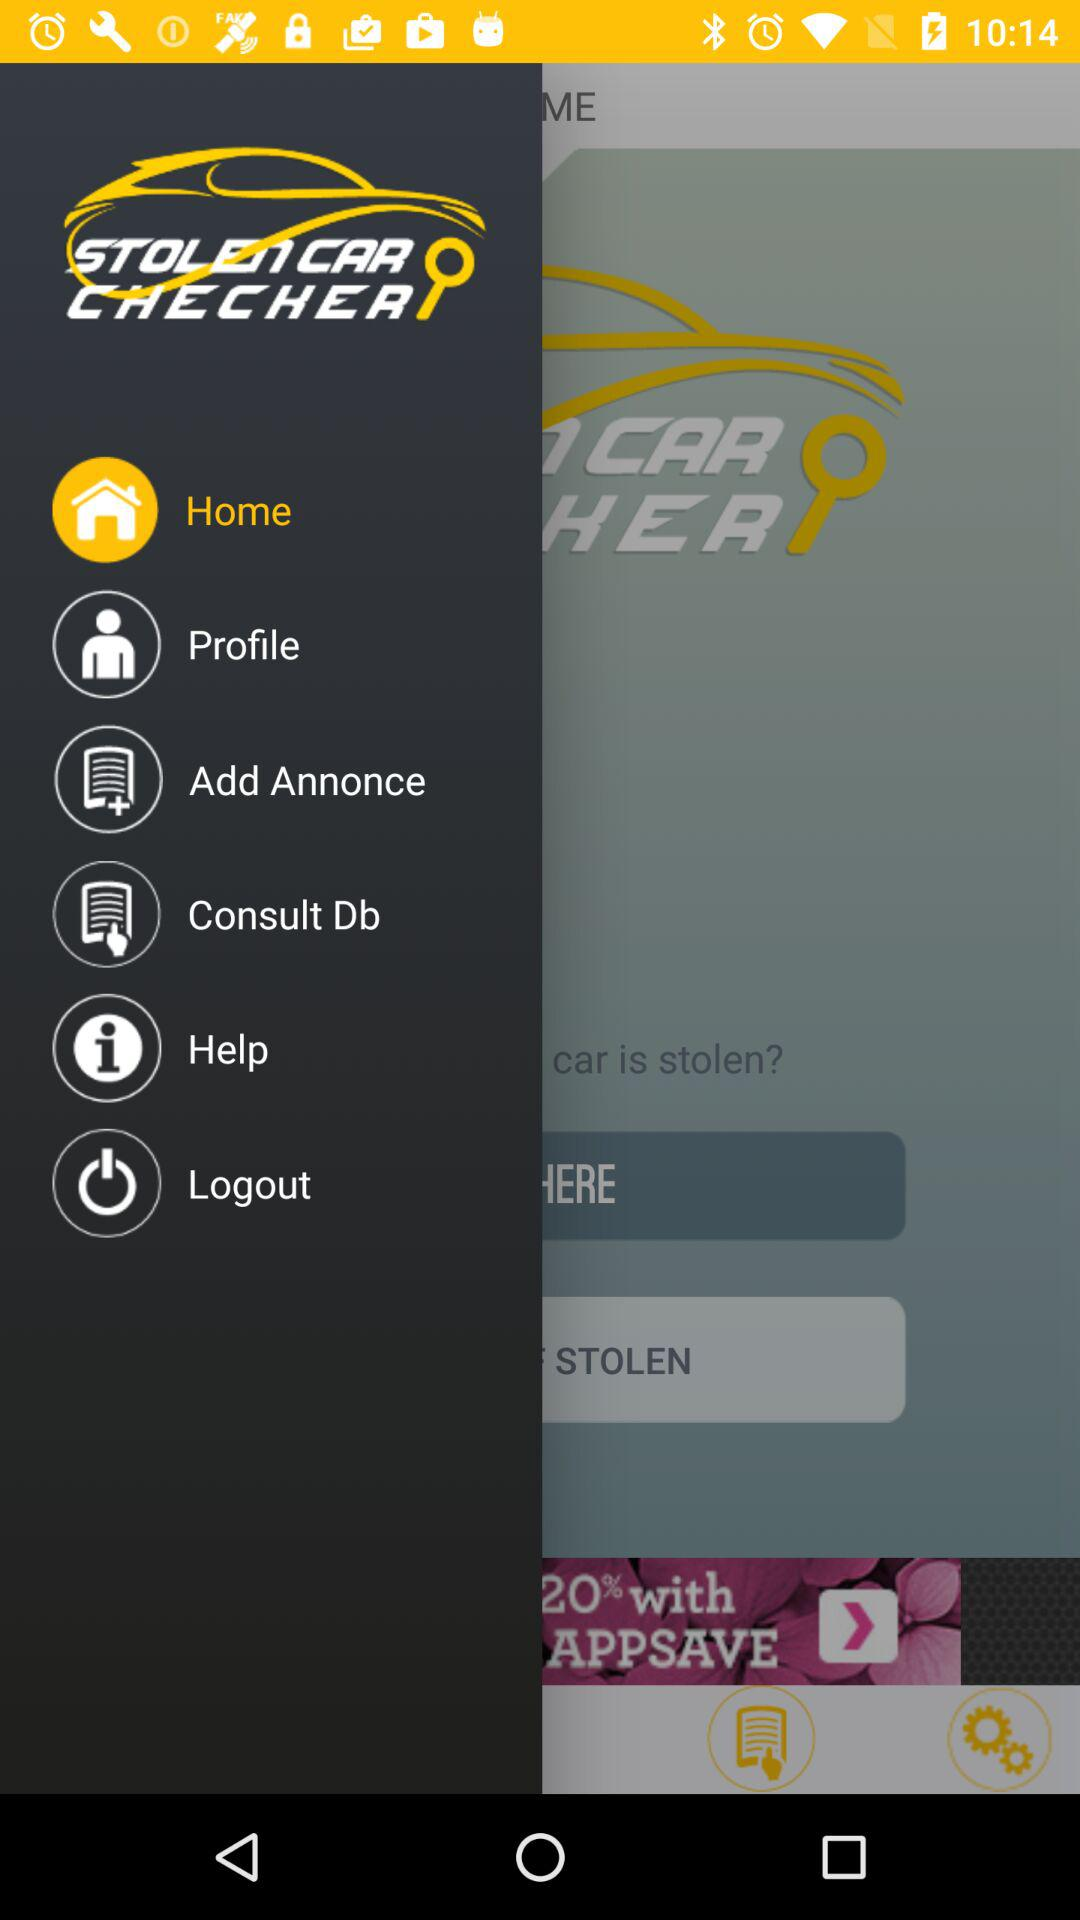What is the selected item in the menu? The selected item in the menu is "Home". 